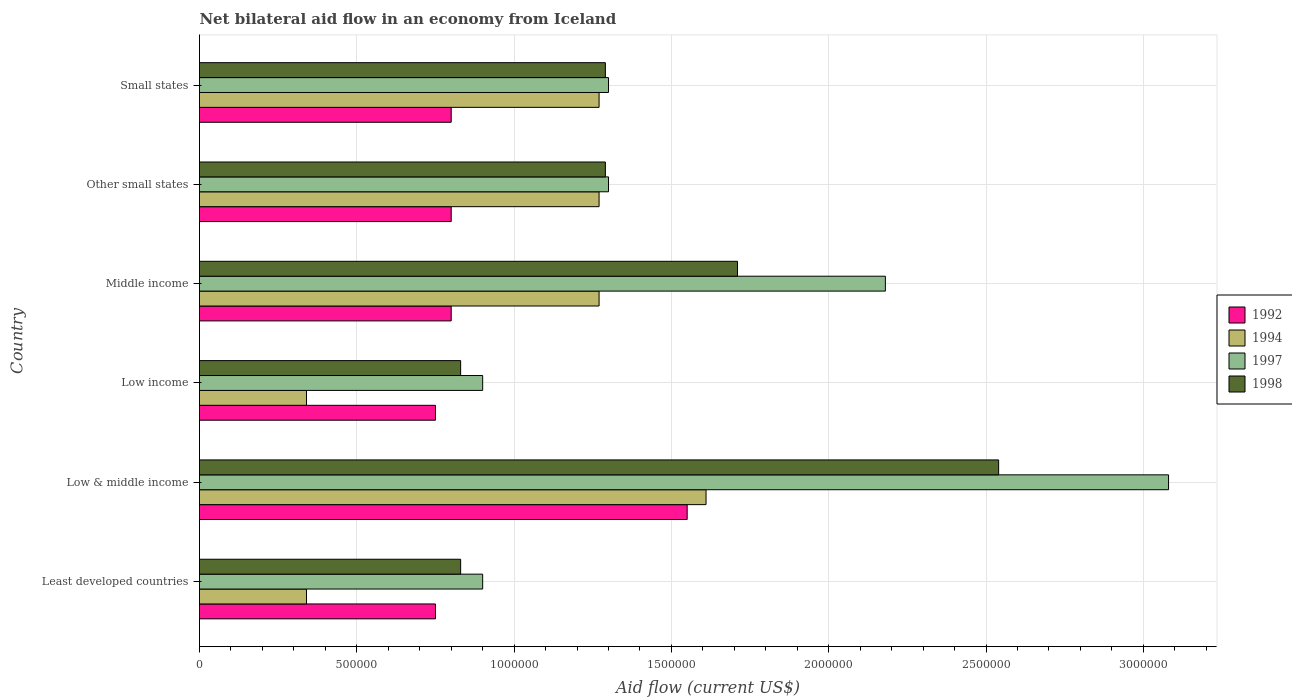How many different coloured bars are there?
Offer a terse response. 4. Are the number of bars per tick equal to the number of legend labels?
Offer a terse response. Yes. Are the number of bars on each tick of the Y-axis equal?
Provide a short and direct response. Yes. How many bars are there on the 1st tick from the top?
Your response must be concise. 4. How many bars are there on the 2nd tick from the bottom?
Ensure brevity in your answer.  4. In how many cases, is the number of bars for a given country not equal to the number of legend labels?
Provide a short and direct response. 0. What is the net bilateral aid flow in 1998 in Middle income?
Offer a very short reply. 1.71e+06. Across all countries, what is the maximum net bilateral aid flow in 1994?
Keep it short and to the point. 1.61e+06. Across all countries, what is the minimum net bilateral aid flow in 1998?
Ensure brevity in your answer.  8.30e+05. In which country was the net bilateral aid flow in 1992 minimum?
Give a very brief answer. Least developed countries. What is the total net bilateral aid flow in 1997 in the graph?
Keep it short and to the point. 9.66e+06. What is the difference between the net bilateral aid flow in 1998 in Low & middle income and that in Middle income?
Make the answer very short. 8.30e+05. What is the difference between the net bilateral aid flow in 1997 in Other small states and the net bilateral aid flow in 1998 in Middle income?
Make the answer very short. -4.10e+05. What is the average net bilateral aid flow in 1994 per country?
Make the answer very short. 1.02e+06. In how many countries, is the net bilateral aid flow in 1994 greater than 800000 US$?
Offer a terse response. 4. What is the ratio of the net bilateral aid flow in 1997 in Low income to that in Middle income?
Your answer should be compact. 0.41. What is the difference between the highest and the second highest net bilateral aid flow in 1998?
Ensure brevity in your answer.  8.30e+05. What is the difference between the highest and the lowest net bilateral aid flow in 1994?
Your answer should be very brief. 1.27e+06. Is it the case that in every country, the sum of the net bilateral aid flow in 1997 and net bilateral aid flow in 1998 is greater than the net bilateral aid flow in 1992?
Your response must be concise. Yes. How many bars are there?
Your answer should be compact. 24. Are the values on the major ticks of X-axis written in scientific E-notation?
Provide a succinct answer. No. Does the graph contain any zero values?
Make the answer very short. No. How many legend labels are there?
Offer a terse response. 4. How are the legend labels stacked?
Provide a succinct answer. Vertical. What is the title of the graph?
Your answer should be very brief. Net bilateral aid flow in an economy from Iceland. Does "2006" appear as one of the legend labels in the graph?
Your answer should be compact. No. What is the label or title of the X-axis?
Keep it short and to the point. Aid flow (current US$). What is the label or title of the Y-axis?
Your answer should be compact. Country. What is the Aid flow (current US$) of 1992 in Least developed countries?
Your answer should be compact. 7.50e+05. What is the Aid flow (current US$) in 1994 in Least developed countries?
Offer a very short reply. 3.40e+05. What is the Aid flow (current US$) of 1998 in Least developed countries?
Offer a terse response. 8.30e+05. What is the Aid flow (current US$) in 1992 in Low & middle income?
Your response must be concise. 1.55e+06. What is the Aid flow (current US$) of 1994 in Low & middle income?
Make the answer very short. 1.61e+06. What is the Aid flow (current US$) of 1997 in Low & middle income?
Provide a short and direct response. 3.08e+06. What is the Aid flow (current US$) of 1998 in Low & middle income?
Offer a terse response. 2.54e+06. What is the Aid flow (current US$) in 1992 in Low income?
Give a very brief answer. 7.50e+05. What is the Aid flow (current US$) in 1994 in Low income?
Ensure brevity in your answer.  3.40e+05. What is the Aid flow (current US$) in 1997 in Low income?
Provide a short and direct response. 9.00e+05. What is the Aid flow (current US$) in 1998 in Low income?
Ensure brevity in your answer.  8.30e+05. What is the Aid flow (current US$) in 1994 in Middle income?
Make the answer very short. 1.27e+06. What is the Aid flow (current US$) in 1997 in Middle income?
Provide a succinct answer. 2.18e+06. What is the Aid flow (current US$) of 1998 in Middle income?
Ensure brevity in your answer.  1.71e+06. What is the Aid flow (current US$) in 1992 in Other small states?
Your answer should be compact. 8.00e+05. What is the Aid flow (current US$) in 1994 in Other small states?
Your response must be concise. 1.27e+06. What is the Aid flow (current US$) in 1997 in Other small states?
Provide a short and direct response. 1.30e+06. What is the Aid flow (current US$) of 1998 in Other small states?
Your response must be concise. 1.29e+06. What is the Aid flow (current US$) in 1994 in Small states?
Provide a succinct answer. 1.27e+06. What is the Aid flow (current US$) in 1997 in Small states?
Provide a succinct answer. 1.30e+06. What is the Aid flow (current US$) of 1998 in Small states?
Offer a terse response. 1.29e+06. Across all countries, what is the maximum Aid flow (current US$) of 1992?
Your answer should be very brief. 1.55e+06. Across all countries, what is the maximum Aid flow (current US$) in 1994?
Offer a very short reply. 1.61e+06. Across all countries, what is the maximum Aid flow (current US$) of 1997?
Offer a very short reply. 3.08e+06. Across all countries, what is the maximum Aid flow (current US$) in 1998?
Make the answer very short. 2.54e+06. Across all countries, what is the minimum Aid flow (current US$) in 1992?
Offer a very short reply. 7.50e+05. Across all countries, what is the minimum Aid flow (current US$) in 1997?
Offer a very short reply. 9.00e+05. Across all countries, what is the minimum Aid flow (current US$) in 1998?
Provide a short and direct response. 8.30e+05. What is the total Aid flow (current US$) in 1992 in the graph?
Your answer should be compact. 5.45e+06. What is the total Aid flow (current US$) in 1994 in the graph?
Your answer should be compact. 6.10e+06. What is the total Aid flow (current US$) of 1997 in the graph?
Make the answer very short. 9.66e+06. What is the total Aid flow (current US$) in 1998 in the graph?
Give a very brief answer. 8.49e+06. What is the difference between the Aid flow (current US$) of 1992 in Least developed countries and that in Low & middle income?
Offer a terse response. -8.00e+05. What is the difference between the Aid flow (current US$) of 1994 in Least developed countries and that in Low & middle income?
Your response must be concise. -1.27e+06. What is the difference between the Aid flow (current US$) in 1997 in Least developed countries and that in Low & middle income?
Keep it short and to the point. -2.18e+06. What is the difference between the Aid flow (current US$) of 1998 in Least developed countries and that in Low & middle income?
Keep it short and to the point. -1.71e+06. What is the difference between the Aid flow (current US$) of 1992 in Least developed countries and that in Low income?
Provide a succinct answer. 0. What is the difference between the Aid flow (current US$) of 1994 in Least developed countries and that in Low income?
Keep it short and to the point. 0. What is the difference between the Aid flow (current US$) in 1997 in Least developed countries and that in Low income?
Keep it short and to the point. 0. What is the difference between the Aid flow (current US$) of 1994 in Least developed countries and that in Middle income?
Give a very brief answer. -9.30e+05. What is the difference between the Aid flow (current US$) in 1997 in Least developed countries and that in Middle income?
Provide a short and direct response. -1.28e+06. What is the difference between the Aid flow (current US$) in 1998 in Least developed countries and that in Middle income?
Offer a very short reply. -8.80e+05. What is the difference between the Aid flow (current US$) of 1994 in Least developed countries and that in Other small states?
Offer a very short reply. -9.30e+05. What is the difference between the Aid flow (current US$) of 1997 in Least developed countries and that in Other small states?
Your answer should be compact. -4.00e+05. What is the difference between the Aid flow (current US$) of 1998 in Least developed countries and that in Other small states?
Keep it short and to the point. -4.60e+05. What is the difference between the Aid flow (current US$) in 1994 in Least developed countries and that in Small states?
Your answer should be very brief. -9.30e+05. What is the difference between the Aid flow (current US$) of 1997 in Least developed countries and that in Small states?
Your response must be concise. -4.00e+05. What is the difference between the Aid flow (current US$) in 1998 in Least developed countries and that in Small states?
Your answer should be compact. -4.60e+05. What is the difference between the Aid flow (current US$) of 1992 in Low & middle income and that in Low income?
Provide a short and direct response. 8.00e+05. What is the difference between the Aid flow (current US$) of 1994 in Low & middle income and that in Low income?
Offer a terse response. 1.27e+06. What is the difference between the Aid flow (current US$) in 1997 in Low & middle income and that in Low income?
Give a very brief answer. 2.18e+06. What is the difference between the Aid flow (current US$) of 1998 in Low & middle income and that in Low income?
Make the answer very short. 1.71e+06. What is the difference between the Aid flow (current US$) in 1992 in Low & middle income and that in Middle income?
Provide a succinct answer. 7.50e+05. What is the difference between the Aid flow (current US$) in 1994 in Low & middle income and that in Middle income?
Provide a short and direct response. 3.40e+05. What is the difference between the Aid flow (current US$) in 1998 in Low & middle income and that in Middle income?
Offer a terse response. 8.30e+05. What is the difference between the Aid flow (current US$) in 1992 in Low & middle income and that in Other small states?
Offer a very short reply. 7.50e+05. What is the difference between the Aid flow (current US$) in 1994 in Low & middle income and that in Other small states?
Offer a terse response. 3.40e+05. What is the difference between the Aid flow (current US$) of 1997 in Low & middle income and that in Other small states?
Your answer should be compact. 1.78e+06. What is the difference between the Aid flow (current US$) in 1998 in Low & middle income and that in Other small states?
Offer a very short reply. 1.25e+06. What is the difference between the Aid flow (current US$) in 1992 in Low & middle income and that in Small states?
Offer a very short reply. 7.50e+05. What is the difference between the Aid flow (current US$) of 1994 in Low & middle income and that in Small states?
Offer a very short reply. 3.40e+05. What is the difference between the Aid flow (current US$) of 1997 in Low & middle income and that in Small states?
Provide a short and direct response. 1.78e+06. What is the difference between the Aid flow (current US$) in 1998 in Low & middle income and that in Small states?
Offer a very short reply. 1.25e+06. What is the difference between the Aid flow (current US$) in 1994 in Low income and that in Middle income?
Your answer should be compact. -9.30e+05. What is the difference between the Aid flow (current US$) of 1997 in Low income and that in Middle income?
Give a very brief answer. -1.28e+06. What is the difference between the Aid flow (current US$) in 1998 in Low income and that in Middle income?
Ensure brevity in your answer.  -8.80e+05. What is the difference between the Aid flow (current US$) of 1992 in Low income and that in Other small states?
Offer a very short reply. -5.00e+04. What is the difference between the Aid flow (current US$) of 1994 in Low income and that in Other small states?
Provide a succinct answer. -9.30e+05. What is the difference between the Aid flow (current US$) of 1997 in Low income and that in Other small states?
Offer a very short reply. -4.00e+05. What is the difference between the Aid flow (current US$) of 1998 in Low income and that in Other small states?
Offer a terse response. -4.60e+05. What is the difference between the Aid flow (current US$) of 1994 in Low income and that in Small states?
Offer a terse response. -9.30e+05. What is the difference between the Aid flow (current US$) of 1997 in Low income and that in Small states?
Offer a very short reply. -4.00e+05. What is the difference between the Aid flow (current US$) of 1998 in Low income and that in Small states?
Make the answer very short. -4.60e+05. What is the difference between the Aid flow (current US$) of 1992 in Middle income and that in Other small states?
Keep it short and to the point. 0. What is the difference between the Aid flow (current US$) of 1994 in Middle income and that in Other small states?
Ensure brevity in your answer.  0. What is the difference between the Aid flow (current US$) in 1997 in Middle income and that in Other small states?
Your answer should be compact. 8.80e+05. What is the difference between the Aid flow (current US$) in 1998 in Middle income and that in Other small states?
Give a very brief answer. 4.20e+05. What is the difference between the Aid flow (current US$) in 1994 in Middle income and that in Small states?
Keep it short and to the point. 0. What is the difference between the Aid flow (current US$) in 1997 in Middle income and that in Small states?
Make the answer very short. 8.80e+05. What is the difference between the Aid flow (current US$) of 1998 in Middle income and that in Small states?
Your answer should be compact. 4.20e+05. What is the difference between the Aid flow (current US$) of 1992 in Other small states and that in Small states?
Provide a short and direct response. 0. What is the difference between the Aid flow (current US$) in 1998 in Other small states and that in Small states?
Make the answer very short. 0. What is the difference between the Aid flow (current US$) of 1992 in Least developed countries and the Aid flow (current US$) of 1994 in Low & middle income?
Ensure brevity in your answer.  -8.60e+05. What is the difference between the Aid flow (current US$) in 1992 in Least developed countries and the Aid flow (current US$) in 1997 in Low & middle income?
Keep it short and to the point. -2.33e+06. What is the difference between the Aid flow (current US$) in 1992 in Least developed countries and the Aid flow (current US$) in 1998 in Low & middle income?
Ensure brevity in your answer.  -1.79e+06. What is the difference between the Aid flow (current US$) of 1994 in Least developed countries and the Aid flow (current US$) of 1997 in Low & middle income?
Ensure brevity in your answer.  -2.74e+06. What is the difference between the Aid flow (current US$) in 1994 in Least developed countries and the Aid flow (current US$) in 1998 in Low & middle income?
Provide a succinct answer. -2.20e+06. What is the difference between the Aid flow (current US$) of 1997 in Least developed countries and the Aid flow (current US$) of 1998 in Low & middle income?
Give a very brief answer. -1.64e+06. What is the difference between the Aid flow (current US$) in 1992 in Least developed countries and the Aid flow (current US$) in 1997 in Low income?
Your answer should be compact. -1.50e+05. What is the difference between the Aid flow (current US$) of 1994 in Least developed countries and the Aid flow (current US$) of 1997 in Low income?
Give a very brief answer. -5.60e+05. What is the difference between the Aid flow (current US$) of 1994 in Least developed countries and the Aid flow (current US$) of 1998 in Low income?
Provide a succinct answer. -4.90e+05. What is the difference between the Aid flow (current US$) in 1997 in Least developed countries and the Aid flow (current US$) in 1998 in Low income?
Make the answer very short. 7.00e+04. What is the difference between the Aid flow (current US$) in 1992 in Least developed countries and the Aid flow (current US$) in 1994 in Middle income?
Give a very brief answer. -5.20e+05. What is the difference between the Aid flow (current US$) of 1992 in Least developed countries and the Aid flow (current US$) of 1997 in Middle income?
Your response must be concise. -1.43e+06. What is the difference between the Aid flow (current US$) of 1992 in Least developed countries and the Aid flow (current US$) of 1998 in Middle income?
Your answer should be very brief. -9.60e+05. What is the difference between the Aid flow (current US$) of 1994 in Least developed countries and the Aid flow (current US$) of 1997 in Middle income?
Provide a short and direct response. -1.84e+06. What is the difference between the Aid flow (current US$) in 1994 in Least developed countries and the Aid flow (current US$) in 1998 in Middle income?
Your answer should be compact. -1.37e+06. What is the difference between the Aid flow (current US$) of 1997 in Least developed countries and the Aid flow (current US$) of 1998 in Middle income?
Your response must be concise. -8.10e+05. What is the difference between the Aid flow (current US$) in 1992 in Least developed countries and the Aid flow (current US$) in 1994 in Other small states?
Make the answer very short. -5.20e+05. What is the difference between the Aid flow (current US$) of 1992 in Least developed countries and the Aid flow (current US$) of 1997 in Other small states?
Provide a short and direct response. -5.50e+05. What is the difference between the Aid flow (current US$) in 1992 in Least developed countries and the Aid flow (current US$) in 1998 in Other small states?
Offer a terse response. -5.40e+05. What is the difference between the Aid flow (current US$) in 1994 in Least developed countries and the Aid flow (current US$) in 1997 in Other small states?
Ensure brevity in your answer.  -9.60e+05. What is the difference between the Aid flow (current US$) in 1994 in Least developed countries and the Aid flow (current US$) in 1998 in Other small states?
Your answer should be very brief. -9.50e+05. What is the difference between the Aid flow (current US$) in 1997 in Least developed countries and the Aid flow (current US$) in 1998 in Other small states?
Offer a terse response. -3.90e+05. What is the difference between the Aid flow (current US$) of 1992 in Least developed countries and the Aid flow (current US$) of 1994 in Small states?
Your answer should be compact. -5.20e+05. What is the difference between the Aid flow (current US$) of 1992 in Least developed countries and the Aid flow (current US$) of 1997 in Small states?
Provide a succinct answer. -5.50e+05. What is the difference between the Aid flow (current US$) in 1992 in Least developed countries and the Aid flow (current US$) in 1998 in Small states?
Give a very brief answer. -5.40e+05. What is the difference between the Aid flow (current US$) of 1994 in Least developed countries and the Aid flow (current US$) of 1997 in Small states?
Offer a very short reply. -9.60e+05. What is the difference between the Aid flow (current US$) in 1994 in Least developed countries and the Aid flow (current US$) in 1998 in Small states?
Offer a terse response. -9.50e+05. What is the difference between the Aid flow (current US$) in 1997 in Least developed countries and the Aid flow (current US$) in 1998 in Small states?
Keep it short and to the point. -3.90e+05. What is the difference between the Aid flow (current US$) of 1992 in Low & middle income and the Aid flow (current US$) of 1994 in Low income?
Your answer should be compact. 1.21e+06. What is the difference between the Aid flow (current US$) in 1992 in Low & middle income and the Aid flow (current US$) in 1997 in Low income?
Your answer should be very brief. 6.50e+05. What is the difference between the Aid flow (current US$) in 1992 in Low & middle income and the Aid flow (current US$) in 1998 in Low income?
Provide a succinct answer. 7.20e+05. What is the difference between the Aid flow (current US$) of 1994 in Low & middle income and the Aid flow (current US$) of 1997 in Low income?
Your answer should be very brief. 7.10e+05. What is the difference between the Aid flow (current US$) of 1994 in Low & middle income and the Aid flow (current US$) of 1998 in Low income?
Your answer should be compact. 7.80e+05. What is the difference between the Aid flow (current US$) in 1997 in Low & middle income and the Aid flow (current US$) in 1998 in Low income?
Give a very brief answer. 2.25e+06. What is the difference between the Aid flow (current US$) of 1992 in Low & middle income and the Aid flow (current US$) of 1994 in Middle income?
Give a very brief answer. 2.80e+05. What is the difference between the Aid flow (current US$) of 1992 in Low & middle income and the Aid flow (current US$) of 1997 in Middle income?
Provide a succinct answer. -6.30e+05. What is the difference between the Aid flow (current US$) in 1992 in Low & middle income and the Aid flow (current US$) in 1998 in Middle income?
Ensure brevity in your answer.  -1.60e+05. What is the difference between the Aid flow (current US$) in 1994 in Low & middle income and the Aid flow (current US$) in 1997 in Middle income?
Your response must be concise. -5.70e+05. What is the difference between the Aid flow (current US$) of 1994 in Low & middle income and the Aid flow (current US$) of 1998 in Middle income?
Your response must be concise. -1.00e+05. What is the difference between the Aid flow (current US$) of 1997 in Low & middle income and the Aid flow (current US$) of 1998 in Middle income?
Provide a short and direct response. 1.37e+06. What is the difference between the Aid flow (current US$) of 1992 in Low & middle income and the Aid flow (current US$) of 1994 in Other small states?
Keep it short and to the point. 2.80e+05. What is the difference between the Aid flow (current US$) in 1992 in Low & middle income and the Aid flow (current US$) in 1997 in Other small states?
Your answer should be very brief. 2.50e+05. What is the difference between the Aid flow (current US$) of 1994 in Low & middle income and the Aid flow (current US$) of 1998 in Other small states?
Your answer should be compact. 3.20e+05. What is the difference between the Aid flow (current US$) of 1997 in Low & middle income and the Aid flow (current US$) of 1998 in Other small states?
Provide a short and direct response. 1.79e+06. What is the difference between the Aid flow (current US$) in 1992 in Low & middle income and the Aid flow (current US$) in 1997 in Small states?
Provide a short and direct response. 2.50e+05. What is the difference between the Aid flow (current US$) in 1994 in Low & middle income and the Aid flow (current US$) in 1998 in Small states?
Provide a succinct answer. 3.20e+05. What is the difference between the Aid flow (current US$) of 1997 in Low & middle income and the Aid flow (current US$) of 1998 in Small states?
Provide a succinct answer. 1.79e+06. What is the difference between the Aid flow (current US$) of 1992 in Low income and the Aid flow (current US$) of 1994 in Middle income?
Your answer should be compact. -5.20e+05. What is the difference between the Aid flow (current US$) of 1992 in Low income and the Aid flow (current US$) of 1997 in Middle income?
Provide a short and direct response. -1.43e+06. What is the difference between the Aid flow (current US$) of 1992 in Low income and the Aid flow (current US$) of 1998 in Middle income?
Your response must be concise. -9.60e+05. What is the difference between the Aid flow (current US$) in 1994 in Low income and the Aid flow (current US$) in 1997 in Middle income?
Provide a succinct answer. -1.84e+06. What is the difference between the Aid flow (current US$) in 1994 in Low income and the Aid flow (current US$) in 1998 in Middle income?
Your answer should be compact. -1.37e+06. What is the difference between the Aid flow (current US$) in 1997 in Low income and the Aid flow (current US$) in 1998 in Middle income?
Your answer should be very brief. -8.10e+05. What is the difference between the Aid flow (current US$) of 1992 in Low income and the Aid flow (current US$) of 1994 in Other small states?
Provide a short and direct response. -5.20e+05. What is the difference between the Aid flow (current US$) in 1992 in Low income and the Aid flow (current US$) in 1997 in Other small states?
Your answer should be compact. -5.50e+05. What is the difference between the Aid flow (current US$) in 1992 in Low income and the Aid flow (current US$) in 1998 in Other small states?
Provide a succinct answer. -5.40e+05. What is the difference between the Aid flow (current US$) of 1994 in Low income and the Aid flow (current US$) of 1997 in Other small states?
Your answer should be very brief. -9.60e+05. What is the difference between the Aid flow (current US$) of 1994 in Low income and the Aid flow (current US$) of 1998 in Other small states?
Provide a short and direct response. -9.50e+05. What is the difference between the Aid flow (current US$) of 1997 in Low income and the Aid flow (current US$) of 1998 in Other small states?
Offer a terse response. -3.90e+05. What is the difference between the Aid flow (current US$) in 1992 in Low income and the Aid flow (current US$) in 1994 in Small states?
Offer a very short reply. -5.20e+05. What is the difference between the Aid flow (current US$) in 1992 in Low income and the Aid flow (current US$) in 1997 in Small states?
Give a very brief answer. -5.50e+05. What is the difference between the Aid flow (current US$) of 1992 in Low income and the Aid flow (current US$) of 1998 in Small states?
Provide a succinct answer. -5.40e+05. What is the difference between the Aid flow (current US$) of 1994 in Low income and the Aid flow (current US$) of 1997 in Small states?
Provide a short and direct response. -9.60e+05. What is the difference between the Aid flow (current US$) of 1994 in Low income and the Aid flow (current US$) of 1998 in Small states?
Keep it short and to the point. -9.50e+05. What is the difference between the Aid flow (current US$) of 1997 in Low income and the Aid flow (current US$) of 1998 in Small states?
Offer a very short reply. -3.90e+05. What is the difference between the Aid flow (current US$) of 1992 in Middle income and the Aid flow (current US$) of 1994 in Other small states?
Your response must be concise. -4.70e+05. What is the difference between the Aid flow (current US$) of 1992 in Middle income and the Aid flow (current US$) of 1997 in Other small states?
Keep it short and to the point. -5.00e+05. What is the difference between the Aid flow (current US$) of 1992 in Middle income and the Aid flow (current US$) of 1998 in Other small states?
Keep it short and to the point. -4.90e+05. What is the difference between the Aid flow (current US$) in 1997 in Middle income and the Aid flow (current US$) in 1998 in Other small states?
Keep it short and to the point. 8.90e+05. What is the difference between the Aid flow (current US$) of 1992 in Middle income and the Aid flow (current US$) of 1994 in Small states?
Your answer should be compact. -4.70e+05. What is the difference between the Aid flow (current US$) of 1992 in Middle income and the Aid flow (current US$) of 1997 in Small states?
Make the answer very short. -5.00e+05. What is the difference between the Aid flow (current US$) in 1992 in Middle income and the Aid flow (current US$) in 1998 in Small states?
Provide a succinct answer. -4.90e+05. What is the difference between the Aid flow (current US$) in 1994 in Middle income and the Aid flow (current US$) in 1997 in Small states?
Ensure brevity in your answer.  -3.00e+04. What is the difference between the Aid flow (current US$) of 1997 in Middle income and the Aid flow (current US$) of 1998 in Small states?
Give a very brief answer. 8.90e+05. What is the difference between the Aid flow (current US$) of 1992 in Other small states and the Aid flow (current US$) of 1994 in Small states?
Make the answer very short. -4.70e+05. What is the difference between the Aid flow (current US$) of 1992 in Other small states and the Aid flow (current US$) of 1997 in Small states?
Ensure brevity in your answer.  -5.00e+05. What is the difference between the Aid flow (current US$) of 1992 in Other small states and the Aid flow (current US$) of 1998 in Small states?
Offer a terse response. -4.90e+05. What is the difference between the Aid flow (current US$) in 1994 in Other small states and the Aid flow (current US$) in 1997 in Small states?
Give a very brief answer. -3.00e+04. What is the difference between the Aid flow (current US$) in 1994 in Other small states and the Aid flow (current US$) in 1998 in Small states?
Your answer should be very brief. -2.00e+04. What is the average Aid flow (current US$) in 1992 per country?
Keep it short and to the point. 9.08e+05. What is the average Aid flow (current US$) of 1994 per country?
Give a very brief answer. 1.02e+06. What is the average Aid flow (current US$) of 1997 per country?
Your answer should be very brief. 1.61e+06. What is the average Aid flow (current US$) in 1998 per country?
Provide a succinct answer. 1.42e+06. What is the difference between the Aid flow (current US$) of 1992 and Aid flow (current US$) of 1994 in Least developed countries?
Offer a terse response. 4.10e+05. What is the difference between the Aid flow (current US$) in 1992 and Aid flow (current US$) in 1997 in Least developed countries?
Give a very brief answer. -1.50e+05. What is the difference between the Aid flow (current US$) in 1992 and Aid flow (current US$) in 1998 in Least developed countries?
Make the answer very short. -8.00e+04. What is the difference between the Aid flow (current US$) of 1994 and Aid flow (current US$) of 1997 in Least developed countries?
Keep it short and to the point. -5.60e+05. What is the difference between the Aid flow (current US$) in 1994 and Aid flow (current US$) in 1998 in Least developed countries?
Give a very brief answer. -4.90e+05. What is the difference between the Aid flow (current US$) of 1992 and Aid flow (current US$) of 1994 in Low & middle income?
Your response must be concise. -6.00e+04. What is the difference between the Aid flow (current US$) of 1992 and Aid flow (current US$) of 1997 in Low & middle income?
Provide a succinct answer. -1.53e+06. What is the difference between the Aid flow (current US$) of 1992 and Aid flow (current US$) of 1998 in Low & middle income?
Your answer should be very brief. -9.90e+05. What is the difference between the Aid flow (current US$) of 1994 and Aid flow (current US$) of 1997 in Low & middle income?
Your response must be concise. -1.47e+06. What is the difference between the Aid flow (current US$) of 1994 and Aid flow (current US$) of 1998 in Low & middle income?
Make the answer very short. -9.30e+05. What is the difference between the Aid flow (current US$) in 1997 and Aid flow (current US$) in 1998 in Low & middle income?
Make the answer very short. 5.40e+05. What is the difference between the Aid flow (current US$) of 1992 and Aid flow (current US$) of 1998 in Low income?
Offer a terse response. -8.00e+04. What is the difference between the Aid flow (current US$) of 1994 and Aid flow (current US$) of 1997 in Low income?
Offer a very short reply. -5.60e+05. What is the difference between the Aid flow (current US$) in 1994 and Aid flow (current US$) in 1998 in Low income?
Offer a terse response. -4.90e+05. What is the difference between the Aid flow (current US$) in 1992 and Aid flow (current US$) in 1994 in Middle income?
Provide a short and direct response. -4.70e+05. What is the difference between the Aid flow (current US$) of 1992 and Aid flow (current US$) of 1997 in Middle income?
Provide a short and direct response. -1.38e+06. What is the difference between the Aid flow (current US$) of 1992 and Aid flow (current US$) of 1998 in Middle income?
Offer a terse response. -9.10e+05. What is the difference between the Aid flow (current US$) in 1994 and Aid flow (current US$) in 1997 in Middle income?
Provide a short and direct response. -9.10e+05. What is the difference between the Aid flow (current US$) in 1994 and Aid flow (current US$) in 1998 in Middle income?
Your answer should be very brief. -4.40e+05. What is the difference between the Aid flow (current US$) of 1992 and Aid flow (current US$) of 1994 in Other small states?
Keep it short and to the point. -4.70e+05. What is the difference between the Aid flow (current US$) in 1992 and Aid flow (current US$) in 1997 in Other small states?
Give a very brief answer. -5.00e+05. What is the difference between the Aid flow (current US$) in 1992 and Aid flow (current US$) in 1998 in Other small states?
Your response must be concise. -4.90e+05. What is the difference between the Aid flow (current US$) in 1994 and Aid flow (current US$) in 1998 in Other small states?
Keep it short and to the point. -2.00e+04. What is the difference between the Aid flow (current US$) of 1997 and Aid flow (current US$) of 1998 in Other small states?
Your answer should be compact. 10000. What is the difference between the Aid flow (current US$) of 1992 and Aid flow (current US$) of 1994 in Small states?
Offer a terse response. -4.70e+05. What is the difference between the Aid flow (current US$) of 1992 and Aid flow (current US$) of 1997 in Small states?
Your response must be concise. -5.00e+05. What is the difference between the Aid flow (current US$) of 1992 and Aid flow (current US$) of 1998 in Small states?
Ensure brevity in your answer.  -4.90e+05. What is the difference between the Aid flow (current US$) in 1997 and Aid flow (current US$) in 1998 in Small states?
Provide a short and direct response. 10000. What is the ratio of the Aid flow (current US$) in 1992 in Least developed countries to that in Low & middle income?
Offer a very short reply. 0.48. What is the ratio of the Aid flow (current US$) of 1994 in Least developed countries to that in Low & middle income?
Ensure brevity in your answer.  0.21. What is the ratio of the Aid flow (current US$) in 1997 in Least developed countries to that in Low & middle income?
Make the answer very short. 0.29. What is the ratio of the Aid flow (current US$) of 1998 in Least developed countries to that in Low & middle income?
Make the answer very short. 0.33. What is the ratio of the Aid flow (current US$) of 1994 in Least developed countries to that in Low income?
Your answer should be compact. 1. What is the ratio of the Aid flow (current US$) in 1997 in Least developed countries to that in Low income?
Keep it short and to the point. 1. What is the ratio of the Aid flow (current US$) of 1992 in Least developed countries to that in Middle income?
Your answer should be very brief. 0.94. What is the ratio of the Aid flow (current US$) of 1994 in Least developed countries to that in Middle income?
Your answer should be compact. 0.27. What is the ratio of the Aid flow (current US$) in 1997 in Least developed countries to that in Middle income?
Your answer should be compact. 0.41. What is the ratio of the Aid flow (current US$) of 1998 in Least developed countries to that in Middle income?
Make the answer very short. 0.49. What is the ratio of the Aid flow (current US$) in 1992 in Least developed countries to that in Other small states?
Your response must be concise. 0.94. What is the ratio of the Aid flow (current US$) of 1994 in Least developed countries to that in Other small states?
Your answer should be very brief. 0.27. What is the ratio of the Aid flow (current US$) in 1997 in Least developed countries to that in Other small states?
Give a very brief answer. 0.69. What is the ratio of the Aid flow (current US$) in 1998 in Least developed countries to that in Other small states?
Make the answer very short. 0.64. What is the ratio of the Aid flow (current US$) in 1994 in Least developed countries to that in Small states?
Give a very brief answer. 0.27. What is the ratio of the Aid flow (current US$) of 1997 in Least developed countries to that in Small states?
Your answer should be very brief. 0.69. What is the ratio of the Aid flow (current US$) of 1998 in Least developed countries to that in Small states?
Provide a short and direct response. 0.64. What is the ratio of the Aid flow (current US$) in 1992 in Low & middle income to that in Low income?
Provide a short and direct response. 2.07. What is the ratio of the Aid flow (current US$) of 1994 in Low & middle income to that in Low income?
Give a very brief answer. 4.74. What is the ratio of the Aid flow (current US$) in 1997 in Low & middle income to that in Low income?
Your response must be concise. 3.42. What is the ratio of the Aid flow (current US$) of 1998 in Low & middle income to that in Low income?
Offer a terse response. 3.06. What is the ratio of the Aid flow (current US$) in 1992 in Low & middle income to that in Middle income?
Keep it short and to the point. 1.94. What is the ratio of the Aid flow (current US$) of 1994 in Low & middle income to that in Middle income?
Make the answer very short. 1.27. What is the ratio of the Aid flow (current US$) of 1997 in Low & middle income to that in Middle income?
Provide a succinct answer. 1.41. What is the ratio of the Aid flow (current US$) in 1998 in Low & middle income to that in Middle income?
Make the answer very short. 1.49. What is the ratio of the Aid flow (current US$) in 1992 in Low & middle income to that in Other small states?
Offer a terse response. 1.94. What is the ratio of the Aid flow (current US$) in 1994 in Low & middle income to that in Other small states?
Ensure brevity in your answer.  1.27. What is the ratio of the Aid flow (current US$) of 1997 in Low & middle income to that in Other small states?
Give a very brief answer. 2.37. What is the ratio of the Aid flow (current US$) of 1998 in Low & middle income to that in Other small states?
Provide a succinct answer. 1.97. What is the ratio of the Aid flow (current US$) in 1992 in Low & middle income to that in Small states?
Your answer should be compact. 1.94. What is the ratio of the Aid flow (current US$) of 1994 in Low & middle income to that in Small states?
Your answer should be compact. 1.27. What is the ratio of the Aid flow (current US$) in 1997 in Low & middle income to that in Small states?
Keep it short and to the point. 2.37. What is the ratio of the Aid flow (current US$) of 1998 in Low & middle income to that in Small states?
Provide a succinct answer. 1.97. What is the ratio of the Aid flow (current US$) in 1994 in Low income to that in Middle income?
Offer a very short reply. 0.27. What is the ratio of the Aid flow (current US$) in 1997 in Low income to that in Middle income?
Provide a succinct answer. 0.41. What is the ratio of the Aid flow (current US$) of 1998 in Low income to that in Middle income?
Offer a very short reply. 0.49. What is the ratio of the Aid flow (current US$) of 1994 in Low income to that in Other small states?
Your answer should be very brief. 0.27. What is the ratio of the Aid flow (current US$) of 1997 in Low income to that in Other small states?
Give a very brief answer. 0.69. What is the ratio of the Aid flow (current US$) in 1998 in Low income to that in Other small states?
Provide a succinct answer. 0.64. What is the ratio of the Aid flow (current US$) of 1992 in Low income to that in Small states?
Provide a succinct answer. 0.94. What is the ratio of the Aid flow (current US$) in 1994 in Low income to that in Small states?
Your answer should be very brief. 0.27. What is the ratio of the Aid flow (current US$) of 1997 in Low income to that in Small states?
Offer a very short reply. 0.69. What is the ratio of the Aid flow (current US$) of 1998 in Low income to that in Small states?
Provide a short and direct response. 0.64. What is the ratio of the Aid flow (current US$) of 1994 in Middle income to that in Other small states?
Give a very brief answer. 1. What is the ratio of the Aid flow (current US$) of 1997 in Middle income to that in Other small states?
Provide a short and direct response. 1.68. What is the ratio of the Aid flow (current US$) in 1998 in Middle income to that in Other small states?
Offer a very short reply. 1.33. What is the ratio of the Aid flow (current US$) of 1997 in Middle income to that in Small states?
Ensure brevity in your answer.  1.68. What is the ratio of the Aid flow (current US$) in 1998 in Middle income to that in Small states?
Your answer should be very brief. 1.33. What is the ratio of the Aid flow (current US$) of 1992 in Other small states to that in Small states?
Give a very brief answer. 1. What is the ratio of the Aid flow (current US$) of 1997 in Other small states to that in Small states?
Your answer should be very brief. 1. What is the difference between the highest and the second highest Aid flow (current US$) in 1992?
Offer a terse response. 7.50e+05. What is the difference between the highest and the second highest Aid flow (current US$) in 1998?
Your answer should be compact. 8.30e+05. What is the difference between the highest and the lowest Aid flow (current US$) of 1992?
Keep it short and to the point. 8.00e+05. What is the difference between the highest and the lowest Aid flow (current US$) of 1994?
Make the answer very short. 1.27e+06. What is the difference between the highest and the lowest Aid flow (current US$) of 1997?
Keep it short and to the point. 2.18e+06. What is the difference between the highest and the lowest Aid flow (current US$) in 1998?
Your answer should be very brief. 1.71e+06. 